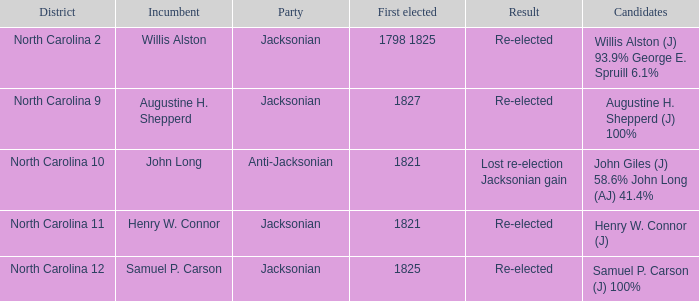What is the combined percentage of party support for willis alston (j) at 93.9% and george e. spruill at 6.1%? 1.0. 